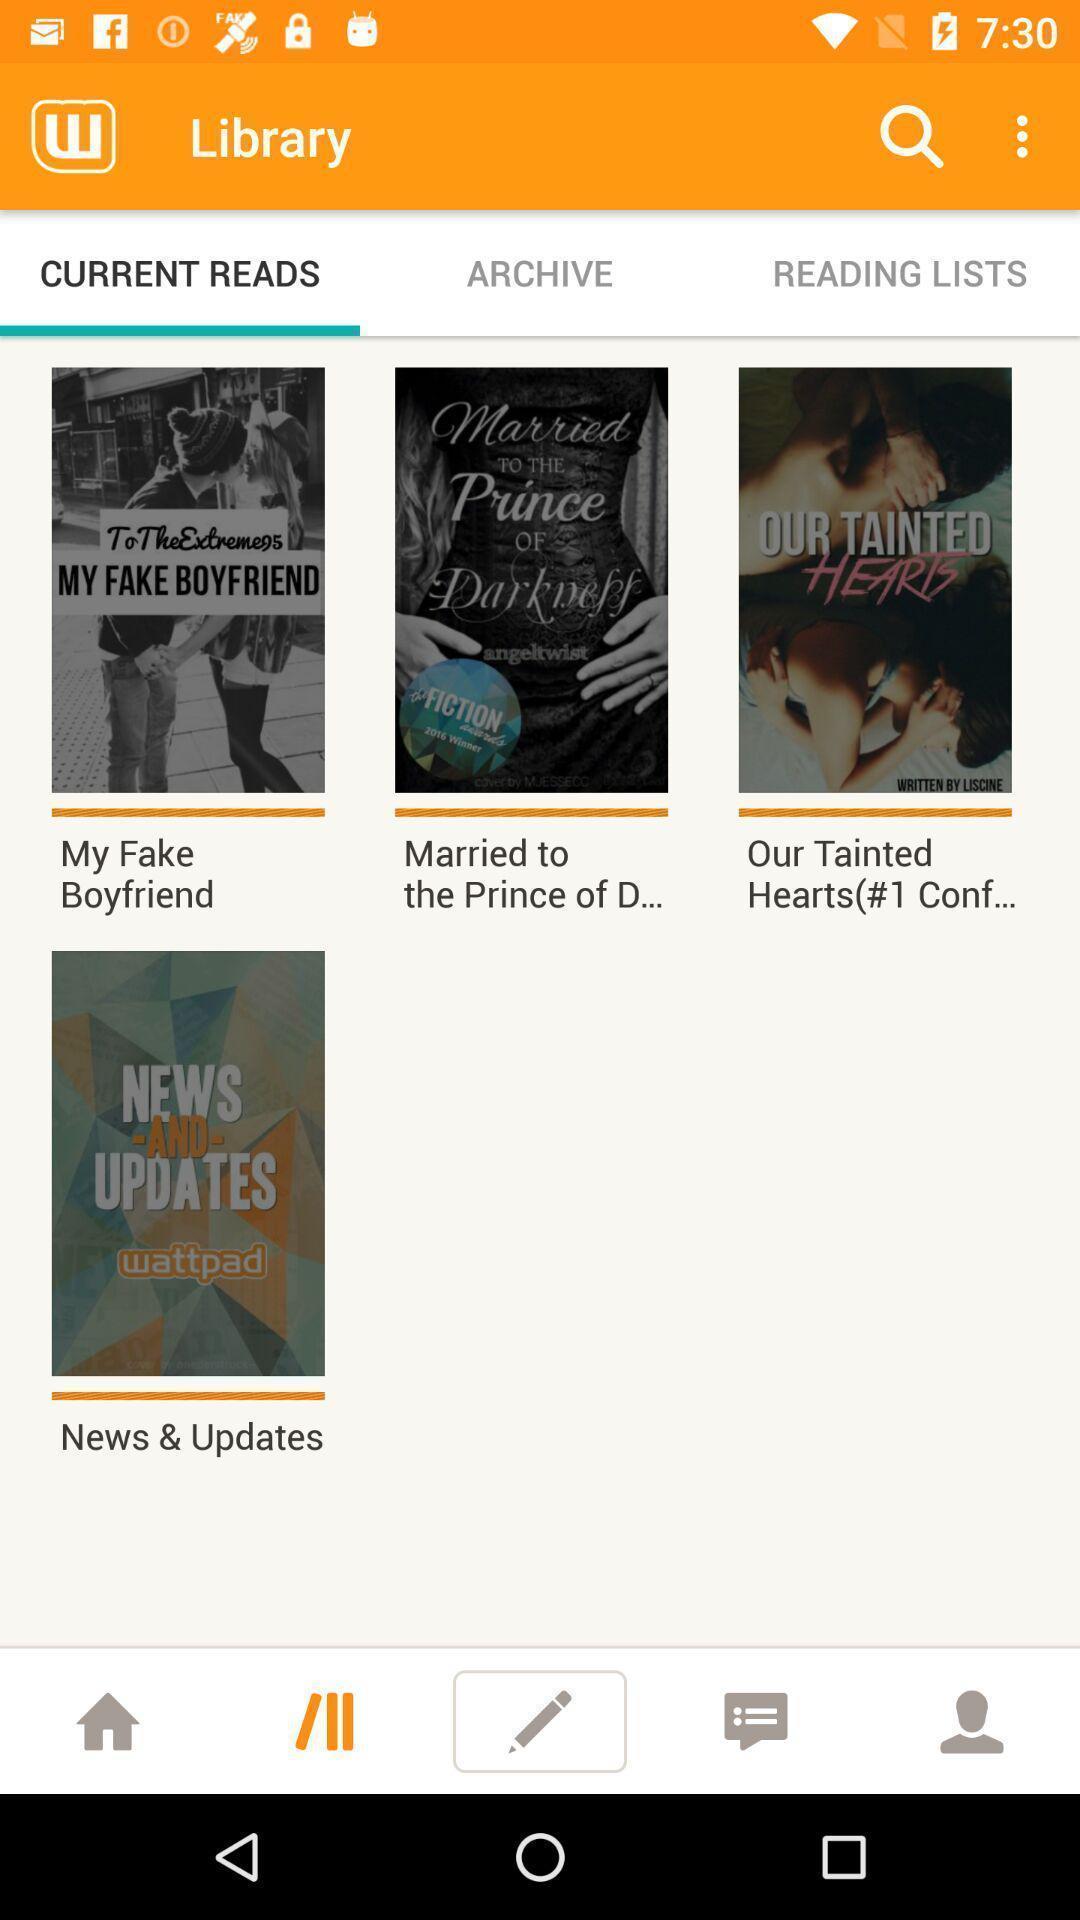Provide a textual representation of this image. Screen displaying multiple stories with names. 